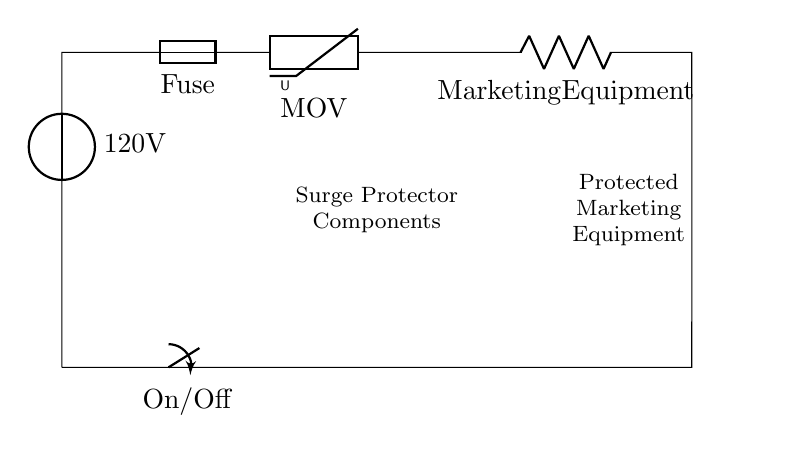What is the voltage of this circuit? The voltage is taken from the source labeled as 120V, which provides the electrical potential for the entire circuit.
Answer: 120V What component is directly before the MOV? The MOV, or Metal Oxide Varistor, is directly preceded by the Fuse in the series circuit. The arrangement flows from the fuse to the varistor in protection against surges.
Answer: Fuse What is the purpose of the fuse in this circuit? The fuse is a safety device that protects the circuit from overload by breaking the connection when the current exceeds a safe level. This helps safeguard the connected equipment from potential damage.
Answer: Overload protection How many main components are in this surge protector circuit? The main components of the circuit listed are the voltage source, fuse, MOV, and marketing equipment, totaling four primary components contributing to the circuit functionality.
Answer: Four What happens when the switch is turned off? When the switch is turned off, it creates an open circuit. This interrupts the current flow, preventing any electrical supply to the marketing equipment and thus protecting it from any power surges or spikes.
Answer: Open circuit What does the term "surge protector" imply about the function of this circuit? The term "surge protector" indicates that the circuit is designed to prevent voltage spikes, enhancing the safety of marketing equipment connected to it by absorbing excess voltage through the MOV.
Answer: Voltage spike protection 